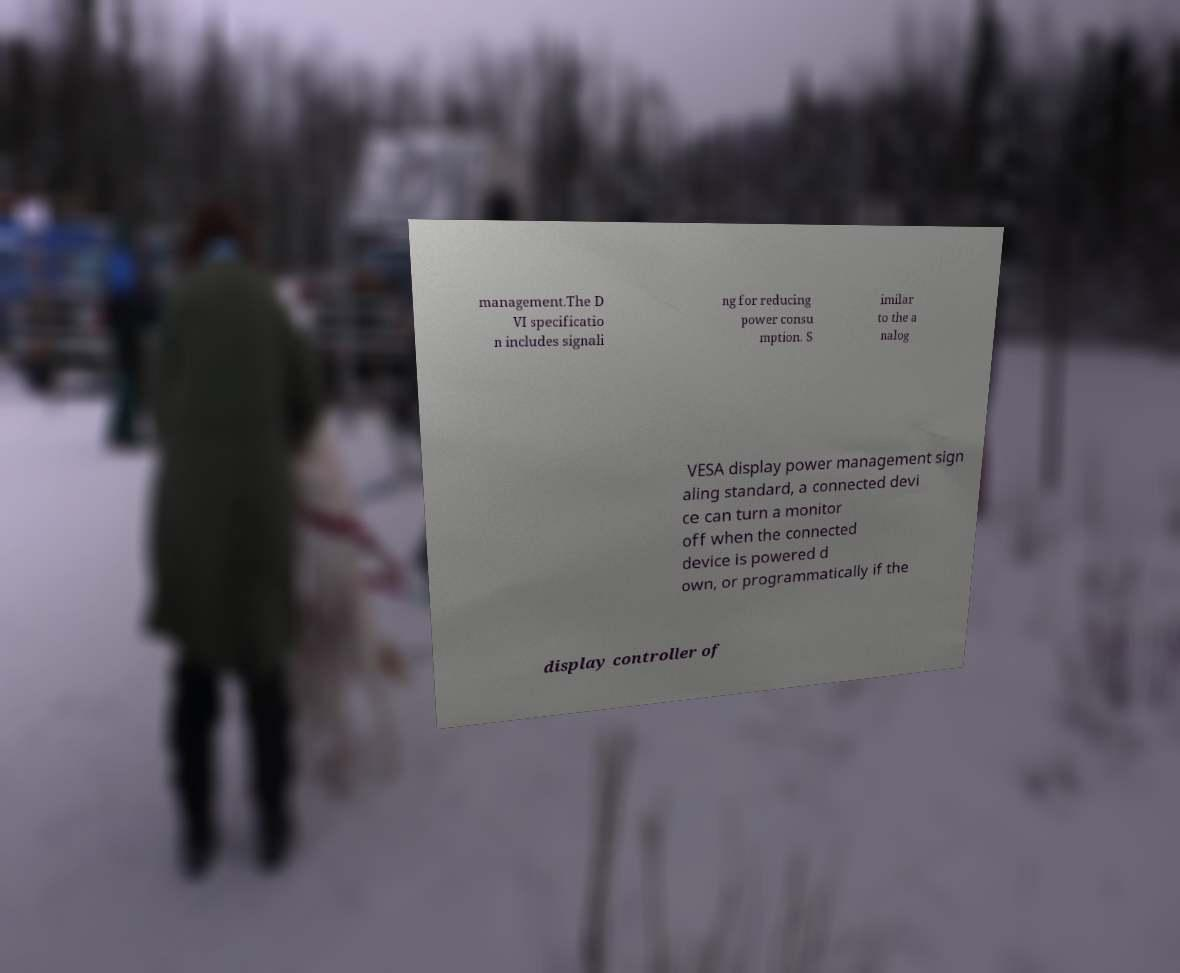Please identify and transcribe the text found in this image. management.The D VI specificatio n includes signali ng for reducing power consu mption. S imilar to the a nalog VESA display power management sign aling standard, a connected devi ce can turn a monitor off when the connected device is powered d own, or programmatically if the display controller of 